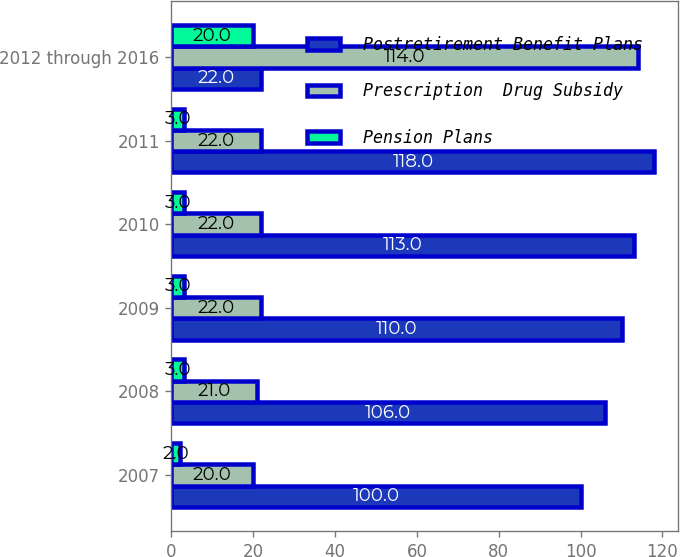Convert chart to OTSL. <chart><loc_0><loc_0><loc_500><loc_500><stacked_bar_chart><ecel><fcel>2007<fcel>2008<fcel>2009<fcel>2010<fcel>2011<fcel>2012 through 2016<nl><fcel>Postretirement Benefit Plans<fcel>100<fcel>106<fcel>110<fcel>113<fcel>118<fcel>22<nl><fcel>Prescription  Drug Subsidy<fcel>20<fcel>21<fcel>22<fcel>22<fcel>22<fcel>114<nl><fcel>Pension Plans<fcel>2<fcel>3<fcel>3<fcel>3<fcel>3<fcel>20<nl></chart> 